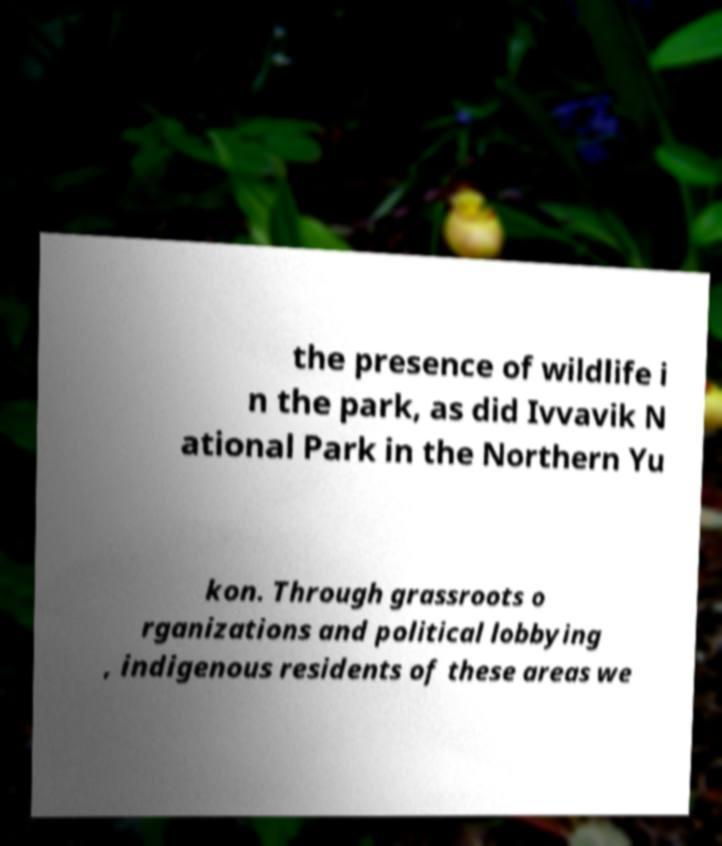For documentation purposes, I need the text within this image transcribed. Could you provide that? the presence of wildlife i n the park, as did Ivvavik N ational Park in the Northern Yu kon. Through grassroots o rganizations and political lobbying , indigenous residents of these areas we 